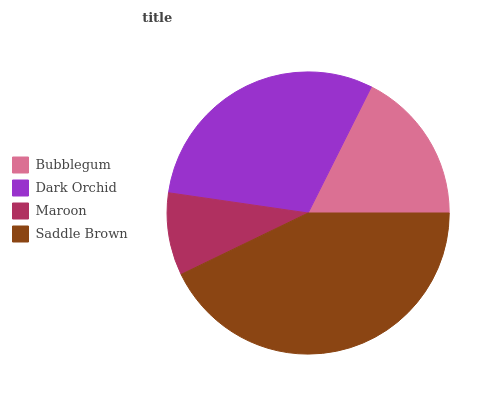Is Maroon the minimum?
Answer yes or no. Yes. Is Saddle Brown the maximum?
Answer yes or no. Yes. Is Dark Orchid the minimum?
Answer yes or no. No. Is Dark Orchid the maximum?
Answer yes or no. No. Is Dark Orchid greater than Bubblegum?
Answer yes or no. Yes. Is Bubblegum less than Dark Orchid?
Answer yes or no. Yes. Is Bubblegum greater than Dark Orchid?
Answer yes or no. No. Is Dark Orchid less than Bubblegum?
Answer yes or no. No. Is Dark Orchid the high median?
Answer yes or no. Yes. Is Bubblegum the low median?
Answer yes or no. Yes. Is Bubblegum the high median?
Answer yes or no. No. Is Saddle Brown the low median?
Answer yes or no. No. 